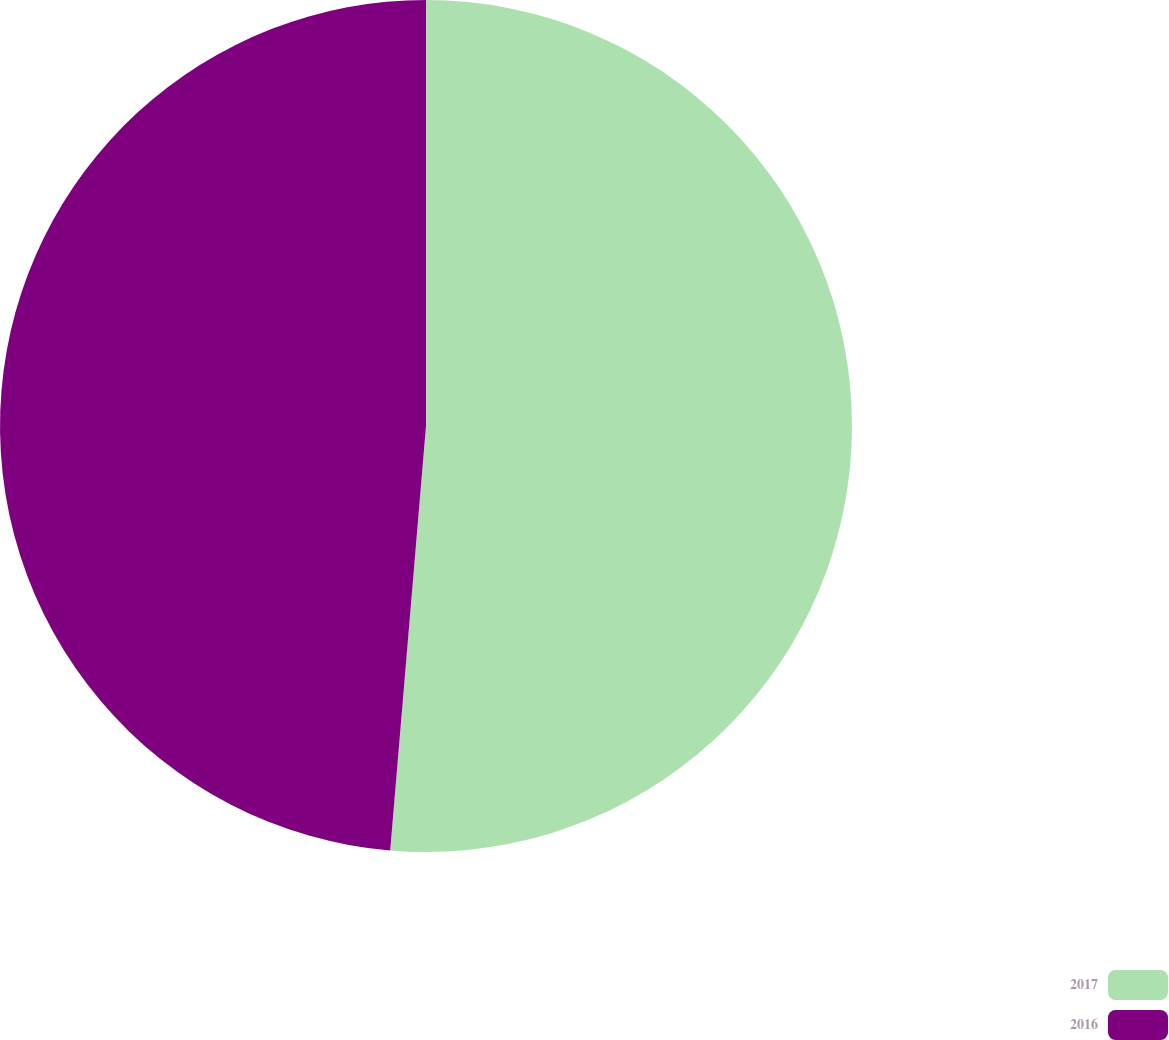<chart> <loc_0><loc_0><loc_500><loc_500><pie_chart><fcel>2017<fcel>2016<nl><fcel>51.34%<fcel>48.66%<nl></chart> 